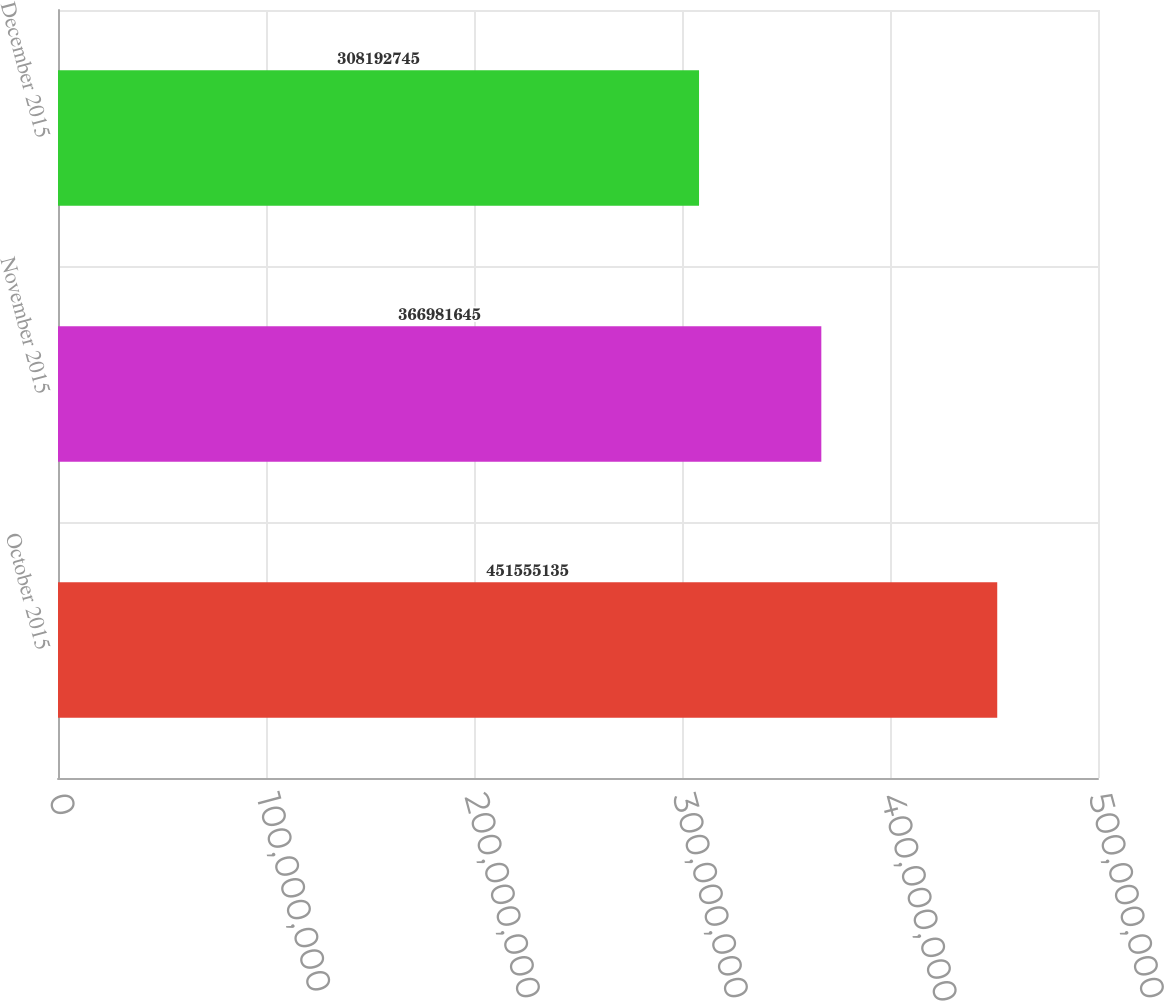Convert chart. <chart><loc_0><loc_0><loc_500><loc_500><bar_chart><fcel>October 2015<fcel>November 2015<fcel>December 2015<nl><fcel>4.51555e+08<fcel>3.66982e+08<fcel>3.08193e+08<nl></chart> 